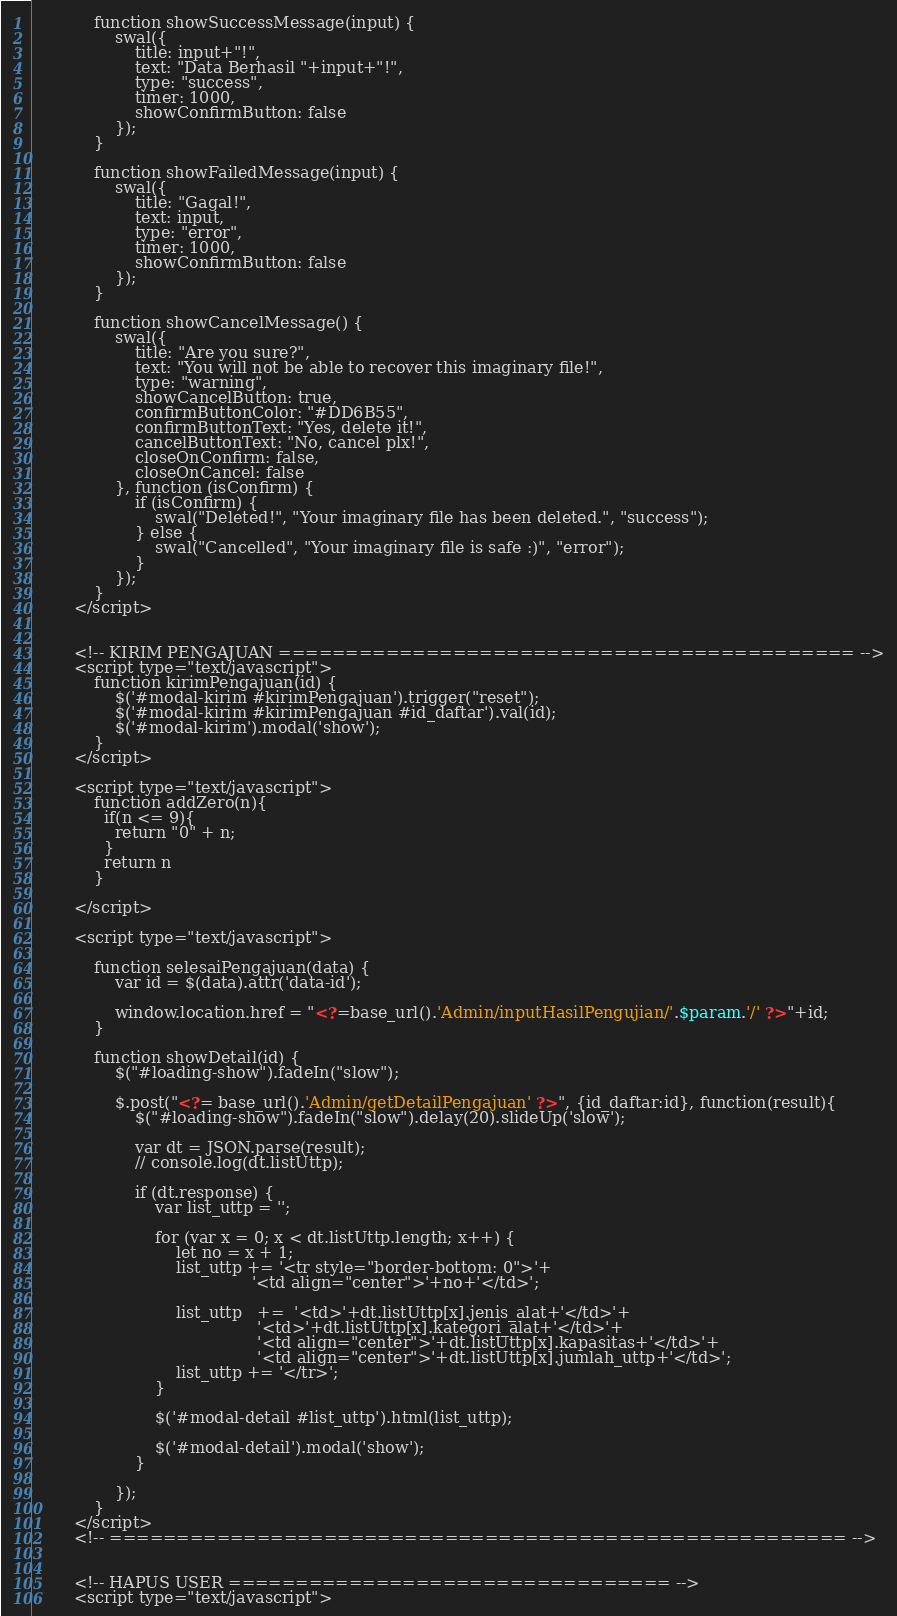<code> <loc_0><loc_0><loc_500><loc_500><_PHP_>
            function showSuccessMessage(input) {
                swal({
                    title: input+"!",
                    text: "Data Berhasil "+input+"!",
                    type: "success",
                    timer: 1000,
                    showConfirmButton: false
                });
            }

            function showFailedMessage(input) {
                swal({
                    title: "Gagal!",
                    text: input,
                    type: "error",
                    timer: 1000,
                    showConfirmButton: false
                });
            }

            function showCancelMessage() {
                swal({
                    title: "Are you sure?",
                    text: "You will not be able to recover this imaginary file!",
                    type: "warning",
                    showCancelButton: true,
                    confirmButtonColor: "#DD6B55",
                    confirmButtonText: "Yes, delete it!",
                    cancelButtonText: "No, cancel plx!",
                    closeOnConfirm: false,
                    closeOnCancel: false
                }, function (isConfirm) {
                    if (isConfirm) {
                        swal("Deleted!", "Your imaginary file has been deleted.", "success");
                    } else {
                        swal("Cancelled", "Your imaginary file is safe :)", "error");
                    }
                });
            }
        </script>


        <!-- KIRIM PENGAJUAN =========================================== -->
        <script type="text/javascript">
            function kirimPengajuan(id) {
                $('#modal-kirim #kirimPengajuan').trigger("reset");
                $('#modal-kirim #kirimPengajuan #id_daftar').val(id);
                $('#modal-kirim').modal('show');
            }
        </script>

        <script type="text/javascript">
            function addZero(n){
              if(n <= 9){
                return "0" + n;
              }
              return n
            }

        </script>

        <script type="text/javascript">

            function selesaiPengajuan(data) {
                var id = $(data).attr('data-id');

                window.location.href = "<?=base_url().'Admin/inputHasilPengujian/'.$param.'/' ?>"+id;
            }

            function showDetail(id) {
                $("#loading-show").fadeIn("slow");

                $.post("<?= base_url().'Admin/getDetailPengajuan' ?>", {id_daftar:id}, function(result){
                    $("#loading-show").fadeIn("slow").delay(20).slideUp('slow');

                    var dt = JSON.parse(result);
                    // console.log(dt.listUttp);

                    if (dt.response) {
                        var list_uttp = '';
                        
                        for (var x = 0; x < dt.listUttp.length; x++) {
                            let no = x + 1;
                            list_uttp += '<tr style="border-bottom: 0">'+
                                           '<td align="center">'+no+'</td>';

                            list_uttp   +=  '<td>'+dt.listUttp[x].jenis_alat+'</td>'+
                                            '<td>'+dt.listUttp[x].kategori_alat+'</td>'+
                                            '<td align="center">'+dt.listUttp[x].kapasitas+'</td>'+
                                            '<td align="center">'+dt.listUttp[x].jumlah_uttp+'</td>';
                            list_uttp += '</tr>';
                        }

                        $('#modal-detail #list_uttp').html(list_uttp);

                        $('#modal-detail').modal('show');
                    }

                });
            }
        </script>
        <!-- ======================================================= -->


        <!-- HAPUS USER ================================= -->
        <script type="text/javascript"></code> 